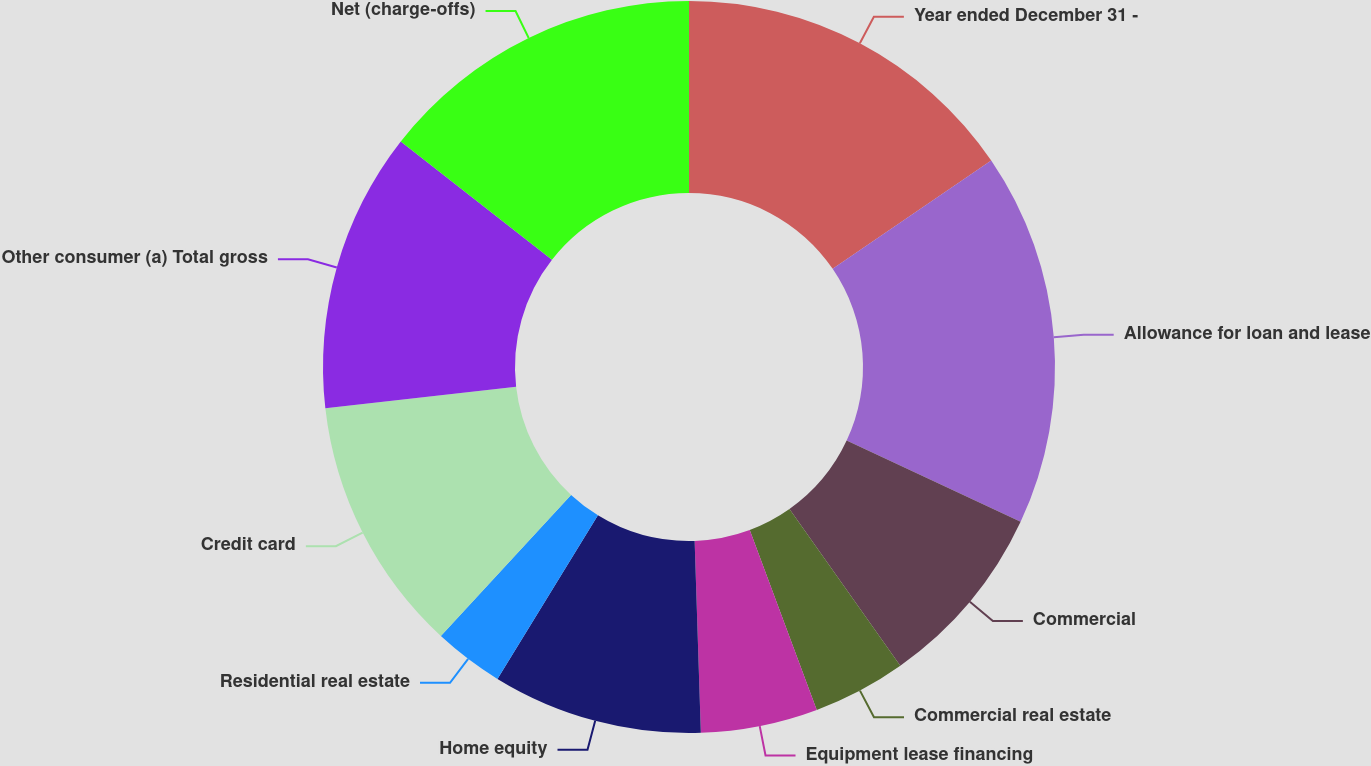Convert chart to OTSL. <chart><loc_0><loc_0><loc_500><loc_500><pie_chart><fcel>Year ended December 31 -<fcel>Allowance for loan and lease<fcel>Commercial<fcel>Commercial real estate<fcel>Equipment lease financing<fcel>Home equity<fcel>Residential real estate<fcel>Credit card<fcel>Other consumer (a) Total gross<fcel>Net (charge-offs)<nl><fcel>15.46%<fcel>16.49%<fcel>8.25%<fcel>4.12%<fcel>5.16%<fcel>9.28%<fcel>3.09%<fcel>11.34%<fcel>12.37%<fcel>14.43%<nl></chart> 